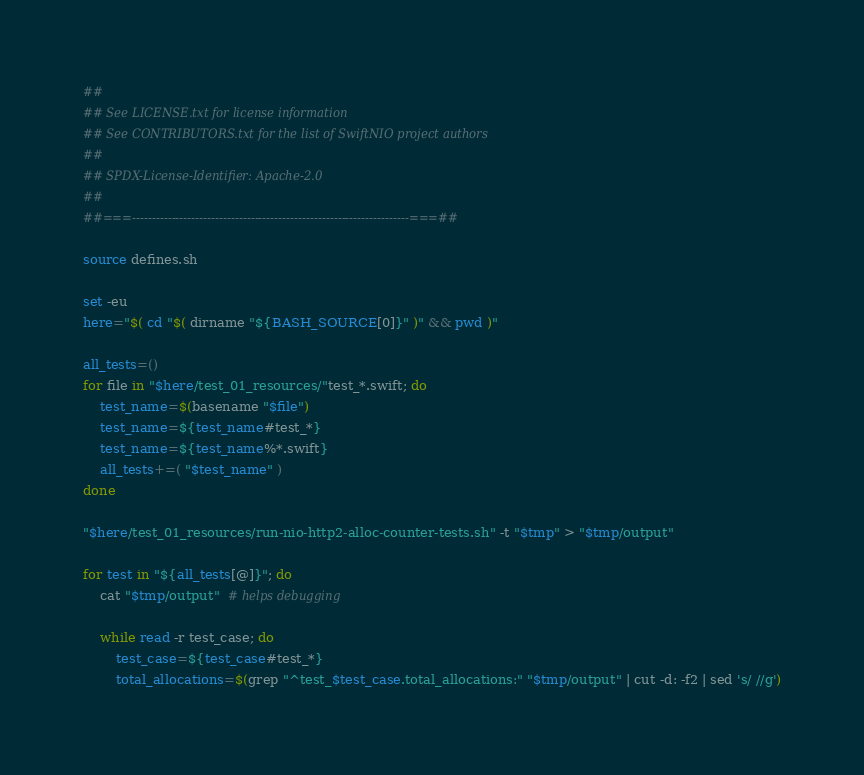Convert code to text. <code><loc_0><loc_0><loc_500><loc_500><_Bash_>##
## See LICENSE.txt for license information
## See CONTRIBUTORS.txt for the list of SwiftNIO project authors
##
## SPDX-License-Identifier: Apache-2.0
##
##===----------------------------------------------------------------------===##

source defines.sh

set -eu
here="$( cd "$( dirname "${BASH_SOURCE[0]}" )" && pwd )"

all_tests=()
for file in "$here/test_01_resources/"test_*.swift; do
    test_name=$(basename "$file")
    test_name=${test_name#test_*}
    test_name=${test_name%*.swift}
    all_tests+=( "$test_name" )
done

"$here/test_01_resources/run-nio-http2-alloc-counter-tests.sh" -t "$tmp" > "$tmp/output"

for test in "${all_tests[@]}"; do
    cat "$tmp/output"  # helps debugging

    while read -r test_case; do
        test_case=${test_case#test_*}
        total_allocations=$(grep "^test_$test_case.total_allocations:" "$tmp/output" | cut -d: -f2 | sed 's/ //g')</code> 